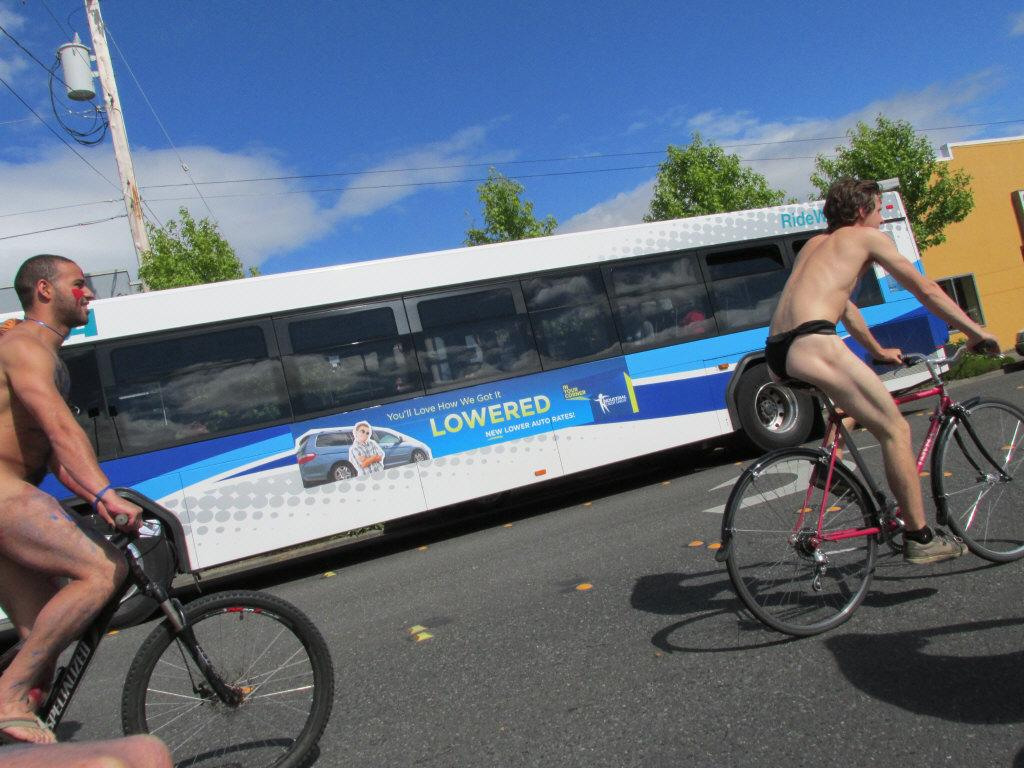Where was the image taken? The image was taken on a road. How many cycles are in the image? There are two cycles in the image. Who is riding the cycles? Two men are riding the cycles. What is behind the cycles? There is a bus behind the cycles. What can be seen in the background of the image? The sky, a pole, and trees are visible in the background. What is the condition of the sky in the image? Clouds are present in the sky. What color of paint is being used by the hen in the image? There is no hen present in the image, and therefore no paint or painting activity can be observed. 